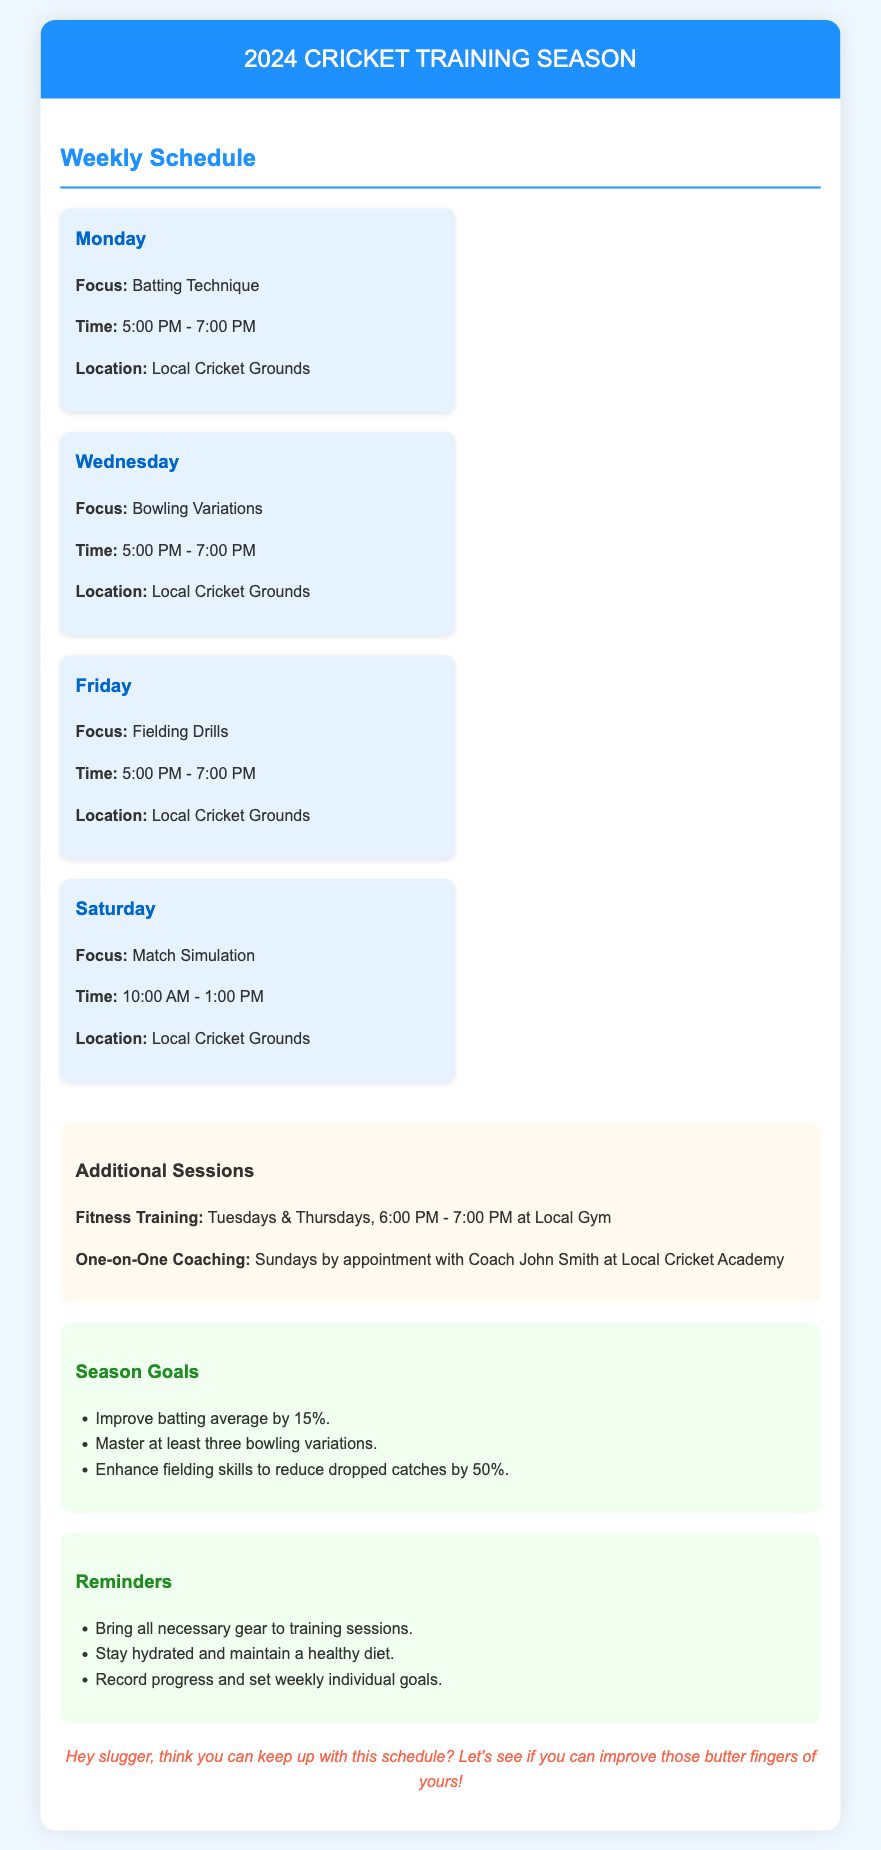What is the focus for training on Monday? The focus for training on Monday is specified under the Monday section of the schedule.
Answer: Batting Technique What time does the Friday training session start? The start time for the Friday session is noted in the Friday section of the schedule.
Answer: 5:00 PM How many goals are listed for the season? The number of goals can be counted from the Season Goals section.
Answer: 3 On which day are fitness training sessions held? This information is in the additional sessions section where fitness training is mentioned.
Answer: Tuesdays & Thursdays What is the duration of the match simulation session? The duration can be calculated based on the time provided in the Saturday section of the schedule.
Answer: 3 hours Which type of training takes place on Wednesdays? This question requires looking at the Wednesday section of the schedule for the focus of training.
Answer: Bowling Variations Who is providing one-on-one coaching? The name of the coach providing one-on-one coaching is given in the additional sessions section.
Answer: Coach John Smith What is the maximum number of participants for one-on-one coaching sessions? The document does not specify, so this is an inference based on typical appointments for coaching.
Answer: Not specified How many reminders are listed in the document? The number of reminders can be found by counting them in the Reminders section.
Answer: 3 